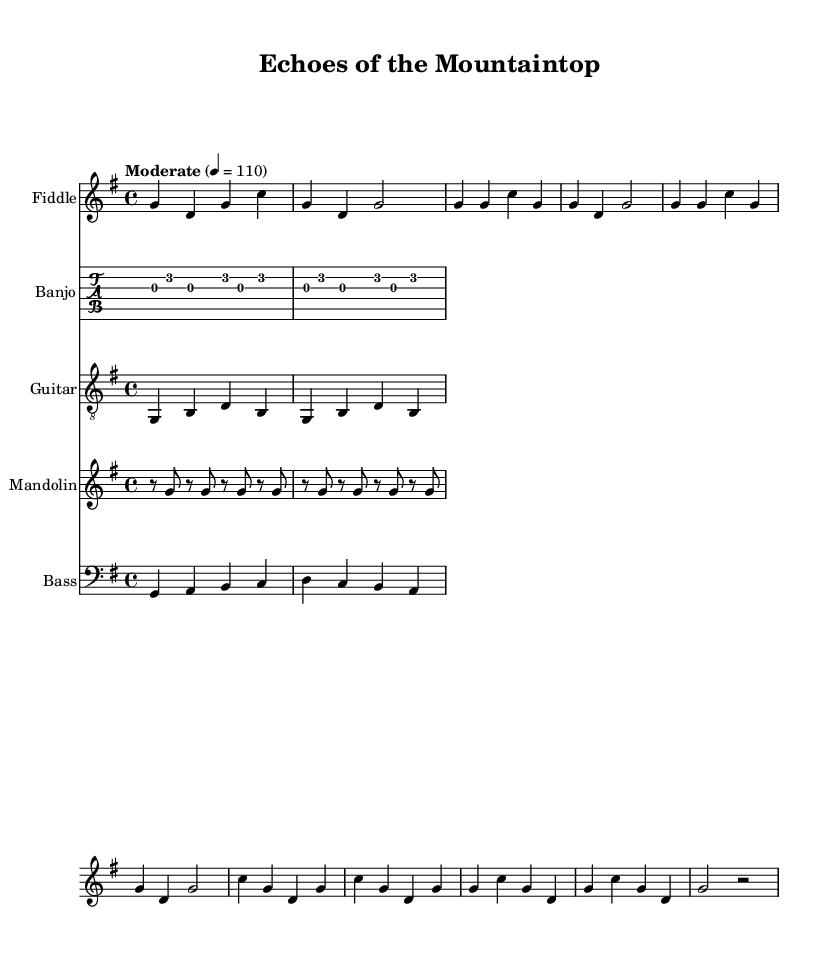What is the key signature of this music? The key signature is G major, which contains one sharp (F#). This can be deduced from the 'g' key indication in the global settings of the code.
Answer: G major What is the time signature of this music? The time signature is 4/4, indicated in the global settings of the music sheet. This means there are four beats per measure and the quarter note gets one beat.
Answer: 4/4 What is the tempo marking of this music? The tempo marking states "Moderate" with a specific BPM of 110, meaning the music should be played at a moderate speed of 110 beats per minute. This is directly stated in the global settings.
Answer: Moderate 110 How many measures are in the verse section? The verse section consists of four measures. By carefully counting the measures in the fiddle line under the verse, we can see it is structured as two sets of two measures each.
Answer: 4 What playing technique is indicated for the banjo part? The banjo part indicates a simplified 'clawhammer' pattern, which is a characteristic technique used in traditional bluegrass music, specifically referenced in the code comments.
Answer: Clawhammer What pattern is used for the mandolin part? The mandolin uses a 'chop on offbeats' pattern, which is typical in bluegrass to provide rhythmic accompaniment, as stated in the comments.
Answer: Chop on offbeats What instrument is indicated to have a walking bass line? The bass line explicitly states it has a 'walking bass line,' which is a common style used to create a smooth, flowing motion in music, detailed in the bass part comments in the code.
Answer: Bass 